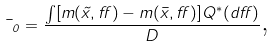<formula> <loc_0><loc_0><loc_500><loc_500>\mu _ { 0 } = \frac { \int [ m ( \tilde { x } , \alpha ) - m ( \bar { x } , \alpha ) ] Q ^ { \ast } ( d \alpha ) } { D } \text {,}</formula> 